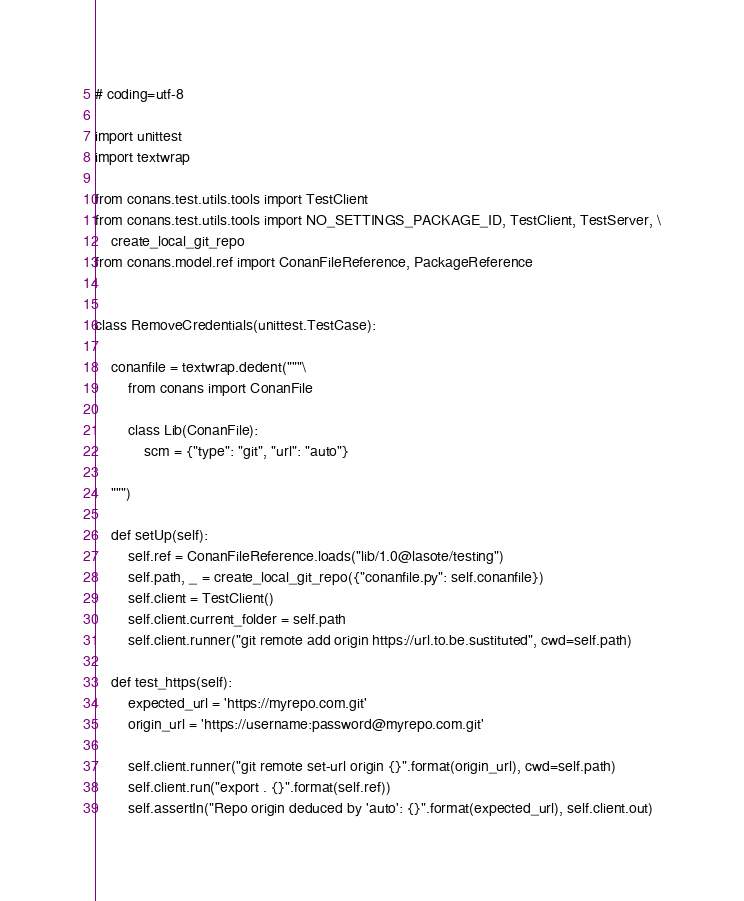<code> <loc_0><loc_0><loc_500><loc_500><_Python_># coding=utf-8

import unittest
import textwrap

from conans.test.utils.tools import TestClient
from conans.test.utils.tools import NO_SETTINGS_PACKAGE_ID, TestClient, TestServer, \
    create_local_git_repo
from conans.model.ref import ConanFileReference, PackageReference


class RemoveCredentials(unittest.TestCase):

    conanfile = textwrap.dedent("""\
        from conans import ConanFile
        
        class Lib(ConanFile):
            scm = {"type": "git", "url": "auto"}
            
    """)

    def setUp(self):
        self.ref = ConanFileReference.loads("lib/1.0@lasote/testing")
        self.path, _ = create_local_git_repo({"conanfile.py": self.conanfile})
        self.client = TestClient()
        self.client.current_folder = self.path
        self.client.runner("git remote add origin https://url.to.be.sustituted", cwd=self.path)

    def test_https(self):
        expected_url = 'https://myrepo.com.git'
        origin_url = 'https://username:password@myrepo.com.git'

        self.client.runner("git remote set-url origin {}".format(origin_url), cwd=self.path)
        self.client.run("export . {}".format(self.ref))
        self.assertIn("Repo origin deduced by 'auto': {}".format(expected_url), self.client.out)
</code> 